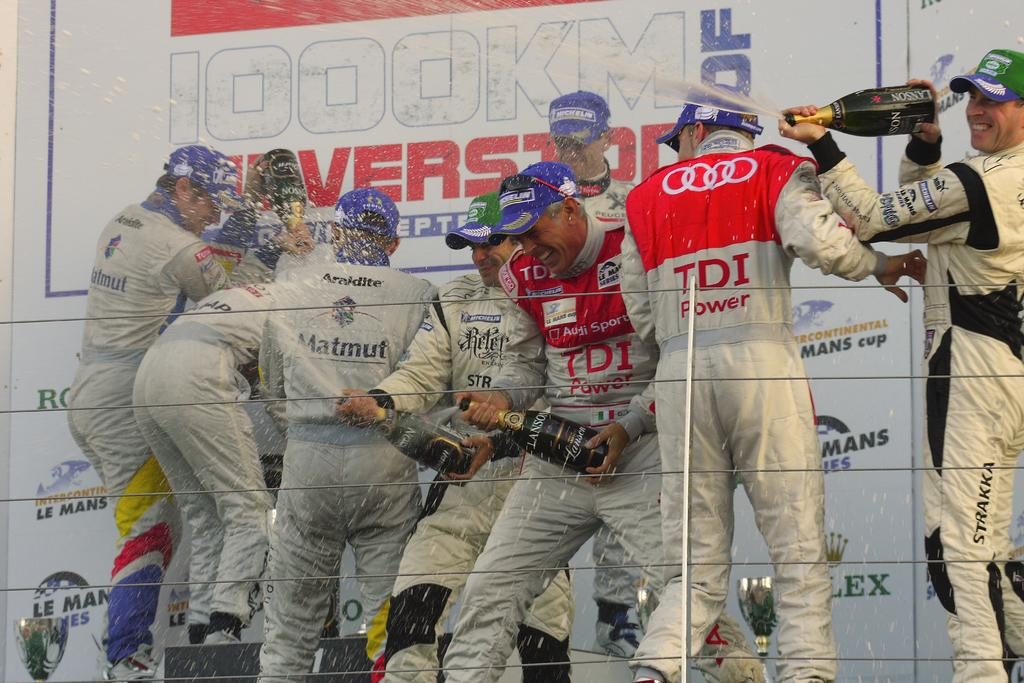<image>
Present a compact description of the photo's key features. Group of people wearing caps and one wearing a shirt that says TDI on it. 